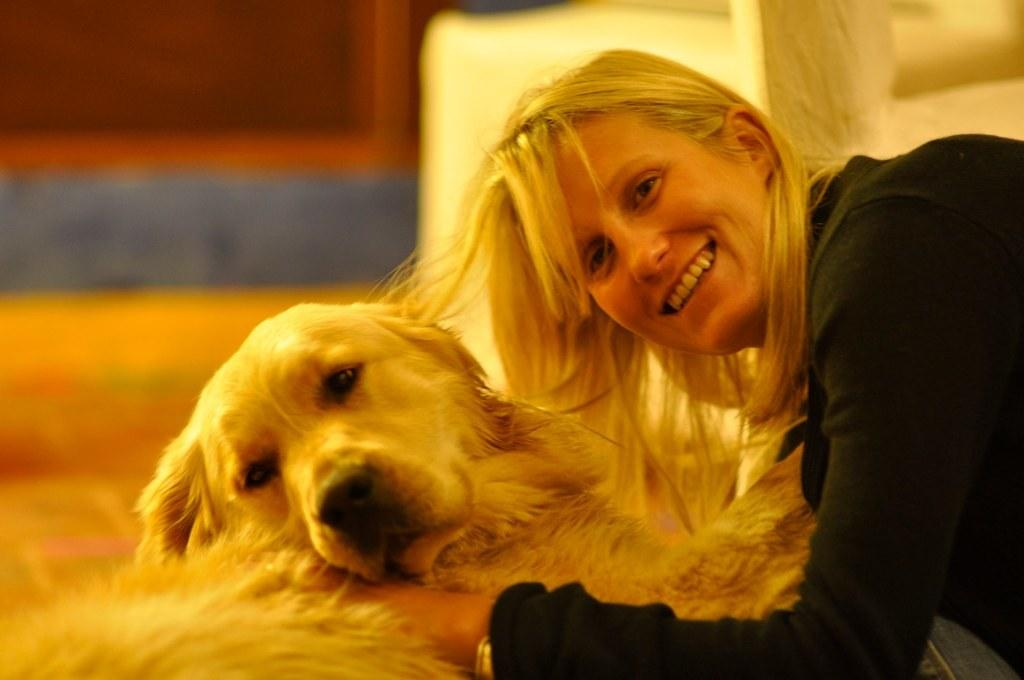Who is present in the image? There is a woman in the image. What is the woman doing in the image? The woman is smiling in the image. Are there any animals present in the image? Yes, there is a dog in the image. What type of selection process is being conducted in the image? There is no indication of a selection process in the image; it simply features a woman and a dog. 